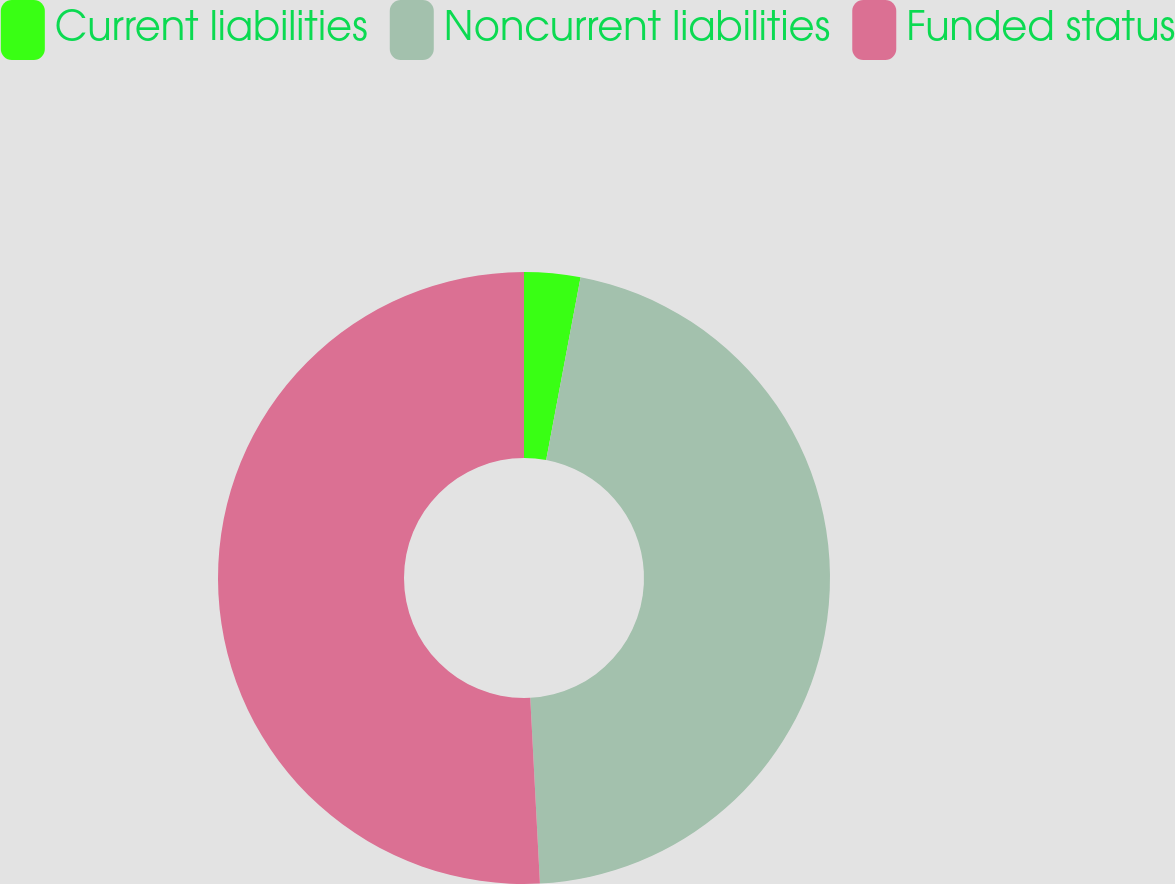Convert chart to OTSL. <chart><loc_0><loc_0><loc_500><loc_500><pie_chart><fcel>Current liabilities<fcel>Noncurrent liabilities<fcel>Funded status<nl><fcel>2.96%<fcel>46.21%<fcel>50.83%<nl></chart> 